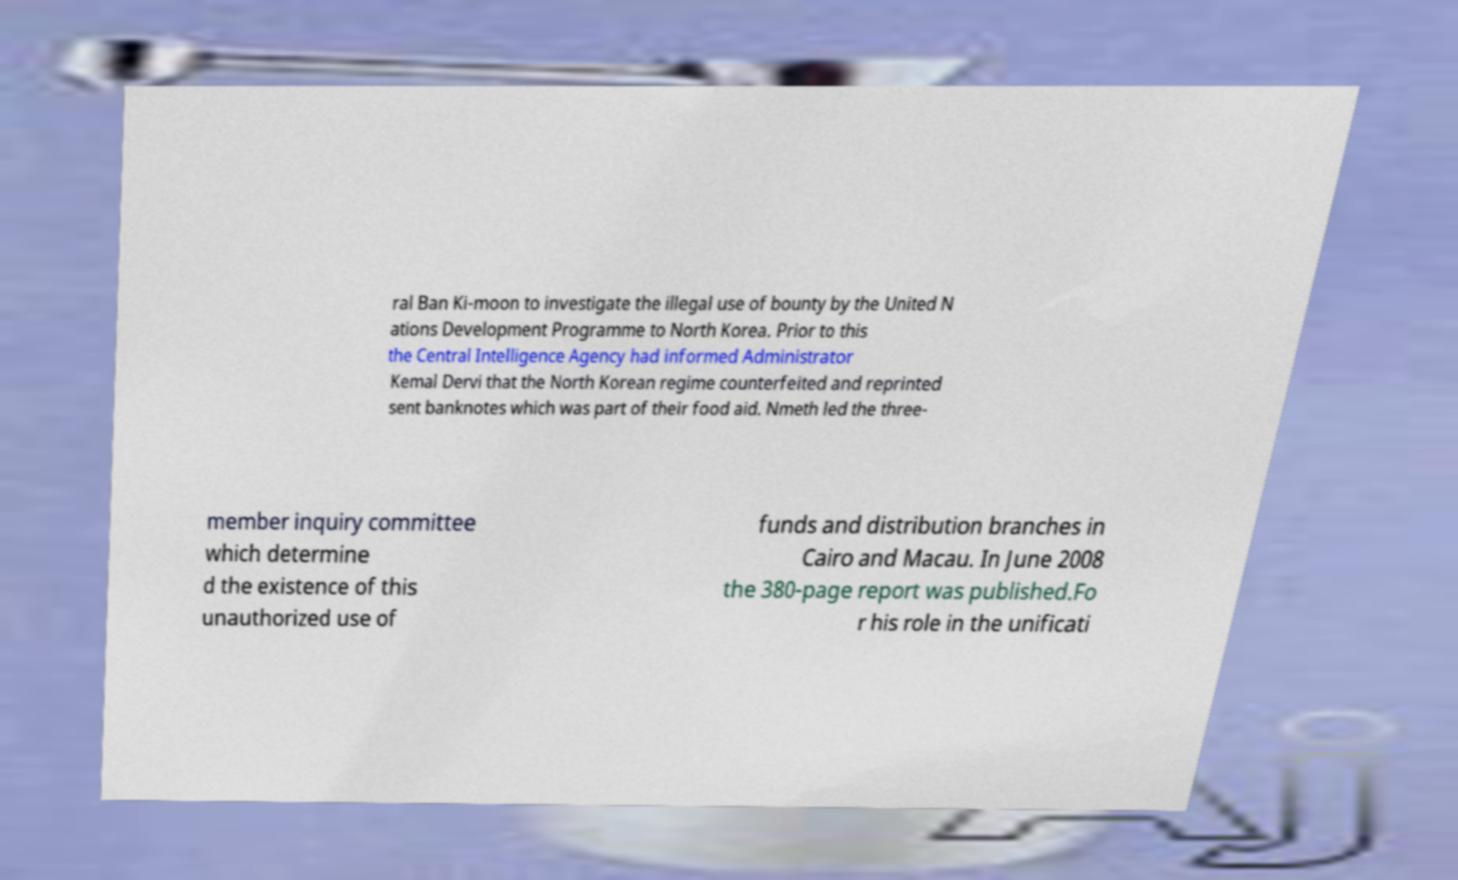Can you read and provide the text displayed in the image?This photo seems to have some interesting text. Can you extract and type it out for me? ral Ban Ki-moon to investigate the illegal use of bounty by the United N ations Development Programme to North Korea. Prior to this the Central Intelligence Agency had informed Administrator Kemal Dervi that the North Korean regime counterfeited and reprinted sent banknotes which was part of their food aid. Nmeth led the three- member inquiry committee which determine d the existence of this unauthorized use of funds and distribution branches in Cairo and Macau. In June 2008 the 380-page report was published.Fo r his role in the unificati 